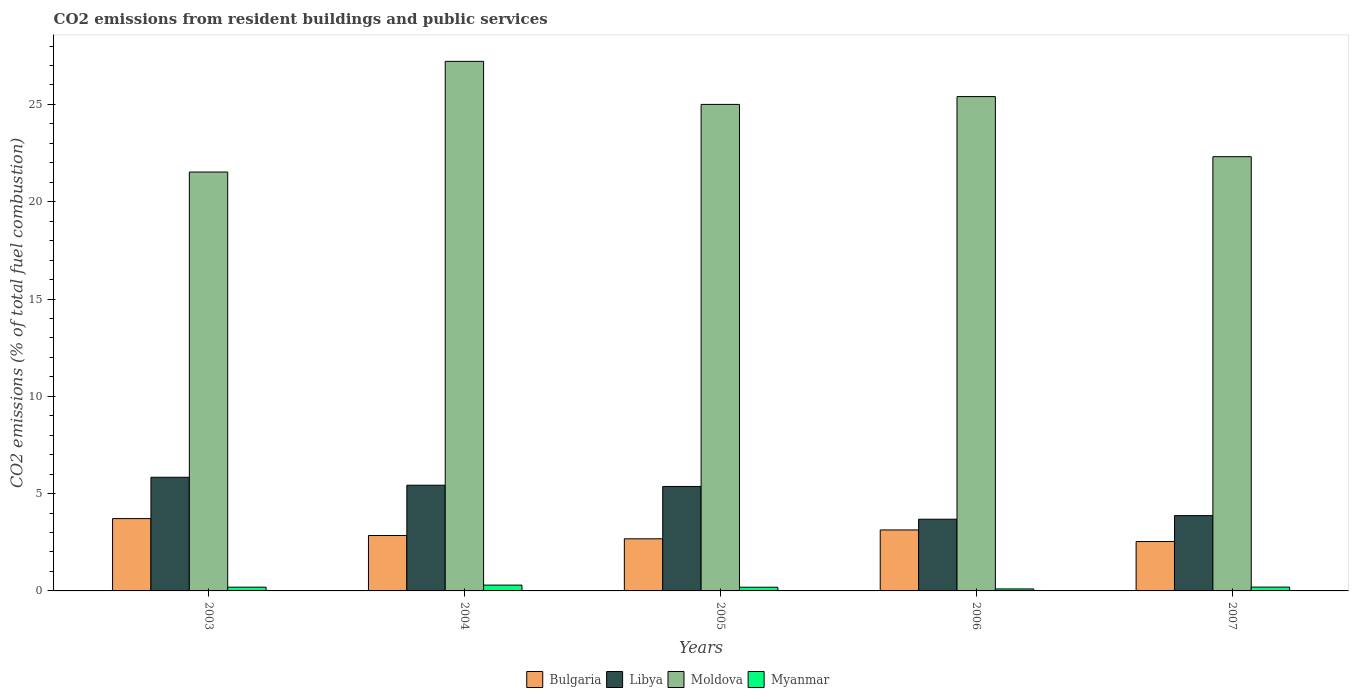How many different coloured bars are there?
Make the answer very short. 4. How many groups of bars are there?
Make the answer very short. 5. Are the number of bars per tick equal to the number of legend labels?
Your answer should be very brief. Yes. How many bars are there on the 2nd tick from the right?
Ensure brevity in your answer.  4. In how many cases, is the number of bars for a given year not equal to the number of legend labels?
Give a very brief answer. 0. What is the total CO2 emitted in Moldova in 2007?
Your response must be concise. 22.31. Across all years, what is the maximum total CO2 emitted in Bulgaria?
Your response must be concise. 3.72. Across all years, what is the minimum total CO2 emitted in Myanmar?
Offer a very short reply. 0.1. In which year was the total CO2 emitted in Myanmar minimum?
Offer a very short reply. 2006. What is the total total CO2 emitted in Moldova in the graph?
Ensure brevity in your answer.  121.45. What is the difference between the total CO2 emitted in Libya in 2005 and that in 2006?
Your answer should be very brief. 1.68. What is the difference between the total CO2 emitted in Myanmar in 2003 and the total CO2 emitted in Moldova in 2004?
Give a very brief answer. -27.02. What is the average total CO2 emitted in Libya per year?
Provide a short and direct response. 4.84. In the year 2006, what is the difference between the total CO2 emitted in Myanmar and total CO2 emitted in Bulgaria?
Your answer should be compact. -3.03. What is the ratio of the total CO2 emitted in Bulgaria in 2005 to that in 2007?
Keep it short and to the point. 1.06. Is the total CO2 emitted in Myanmar in 2003 less than that in 2005?
Offer a terse response. No. Is the difference between the total CO2 emitted in Myanmar in 2005 and 2007 greater than the difference between the total CO2 emitted in Bulgaria in 2005 and 2007?
Give a very brief answer. No. What is the difference between the highest and the second highest total CO2 emitted in Myanmar?
Your response must be concise. 0.1. What is the difference between the highest and the lowest total CO2 emitted in Moldova?
Provide a short and direct response. 5.69. Is the sum of the total CO2 emitted in Myanmar in 2003 and 2007 greater than the maximum total CO2 emitted in Libya across all years?
Offer a very short reply. No. Is it the case that in every year, the sum of the total CO2 emitted in Moldova and total CO2 emitted in Libya is greater than the sum of total CO2 emitted in Bulgaria and total CO2 emitted in Myanmar?
Your response must be concise. Yes. What does the 4th bar from the left in 2003 represents?
Make the answer very short. Myanmar. What does the 2nd bar from the right in 2006 represents?
Provide a succinct answer. Moldova. Is it the case that in every year, the sum of the total CO2 emitted in Moldova and total CO2 emitted in Myanmar is greater than the total CO2 emitted in Libya?
Offer a very short reply. Yes. How many bars are there?
Your answer should be compact. 20. Are all the bars in the graph horizontal?
Ensure brevity in your answer.  No. How many years are there in the graph?
Offer a terse response. 5. What is the difference between two consecutive major ticks on the Y-axis?
Offer a terse response. 5. Does the graph contain grids?
Offer a terse response. No. Where does the legend appear in the graph?
Provide a short and direct response. Bottom center. How are the legend labels stacked?
Your answer should be compact. Horizontal. What is the title of the graph?
Your answer should be very brief. CO2 emissions from resident buildings and public services. Does "Mauritius" appear as one of the legend labels in the graph?
Provide a succinct answer. No. What is the label or title of the Y-axis?
Your response must be concise. CO2 emissions (% of total fuel combustion). What is the CO2 emissions (% of total fuel combustion) in Bulgaria in 2003?
Make the answer very short. 3.72. What is the CO2 emissions (% of total fuel combustion) in Libya in 2003?
Keep it short and to the point. 5.84. What is the CO2 emissions (% of total fuel combustion) in Moldova in 2003?
Your response must be concise. 21.52. What is the CO2 emissions (% of total fuel combustion) of Myanmar in 2003?
Make the answer very short. 0.19. What is the CO2 emissions (% of total fuel combustion) in Bulgaria in 2004?
Ensure brevity in your answer.  2.85. What is the CO2 emissions (% of total fuel combustion) of Libya in 2004?
Make the answer very short. 5.43. What is the CO2 emissions (% of total fuel combustion) in Moldova in 2004?
Give a very brief answer. 27.21. What is the CO2 emissions (% of total fuel combustion) of Myanmar in 2004?
Offer a terse response. 0.3. What is the CO2 emissions (% of total fuel combustion) in Bulgaria in 2005?
Your answer should be very brief. 2.68. What is the CO2 emissions (% of total fuel combustion) of Libya in 2005?
Provide a succinct answer. 5.37. What is the CO2 emissions (% of total fuel combustion) of Moldova in 2005?
Offer a very short reply. 25. What is the CO2 emissions (% of total fuel combustion) of Myanmar in 2005?
Ensure brevity in your answer.  0.19. What is the CO2 emissions (% of total fuel combustion) of Bulgaria in 2006?
Your response must be concise. 3.13. What is the CO2 emissions (% of total fuel combustion) of Libya in 2006?
Your answer should be compact. 3.68. What is the CO2 emissions (% of total fuel combustion) of Moldova in 2006?
Make the answer very short. 25.4. What is the CO2 emissions (% of total fuel combustion) in Myanmar in 2006?
Your response must be concise. 0.1. What is the CO2 emissions (% of total fuel combustion) in Bulgaria in 2007?
Make the answer very short. 2.54. What is the CO2 emissions (% of total fuel combustion) in Libya in 2007?
Your response must be concise. 3.87. What is the CO2 emissions (% of total fuel combustion) of Moldova in 2007?
Offer a very short reply. 22.31. What is the CO2 emissions (% of total fuel combustion) of Myanmar in 2007?
Keep it short and to the point. 0.2. Across all years, what is the maximum CO2 emissions (% of total fuel combustion) of Bulgaria?
Offer a terse response. 3.72. Across all years, what is the maximum CO2 emissions (% of total fuel combustion) of Libya?
Your response must be concise. 5.84. Across all years, what is the maximum CO2 emissions (% of total fuel combustion) of Moldova?
Make the answer very short. 27.21. Across all years, what is the maximum CO2 emissions (% of total fuel combustion) of Myanmar?
Offer a very short reply. 0.3. Across all years, what is the minimum CO2 emissions (% of total fuel combustion) of Bulgaria?
Offer a terse response. 2.54. Across all years, what is the minimum CO2 emissions (% of total fuel combustion) in Libya?
Give a very brief answer. 3.68. Across all years, what is the minimum CO2 emissions (% of total fuel combustion) of Moldova?
Give a very brief answer. 21.52. Across all years, what is the minimum CO2 emissions (% of total fuel combustion) in Myanmar?
Give a very brief answer. 0.1. What is the total CO2 emissions (% of total fuel combustion) of Bulgaria in the graph?
Provide a short and direct response. 14.91. What is the total CO2 emissions (% of total fuel combustion) of Libya in the graph?
Ensure brevity in your answer.  24.19. What is the total CO2 emissions (% of total fuel combustion) of Moldova in the graph?
Make the answer very short. 121.45. What is the total CO2 emissions (% of total fuel combustion) of Myanmar in the graph?
Offer a terse response. 0.98. What is the difference between the CO2 emissions (% of total fuel combustion) in Bulgaria in 2003 and that in 2004?
Your answer should be very brief. 0.87. What is the difference between the CO2 emissions (% of total fuel combustion) in Libya in 2003 and that in 2004?
Your answer should be compact. 0.41. What is the difference between the CO2 emissions (% of total fuel combustion) in Moldova in 2003 and that in 2004?
Offer a very short reply. -5.69. What is the difference between the CO2 emissions (% of total fuel combustion) of Myanmar in 2003 and that in 2004?
Keep it short and to the point. -0.11. What is the difference between the CO2 emissions (% of total fuel combustion) of Bulgaria in 2003 and that in 2005?
Offer a very short reply. 1.04. What is the difference between the CO2 emissions (% of total fuel combustion) of Libya in 2003 and that in 2005?
Give a very brief answer. 0.47. What is the difference between the CO2 emissions (% of total fuel combustion) in Moldova in 2003 and that in 2005?
Ensure brevity in your answer.  -3.48. What is the difference between the CO2 emissions (% of total fuel combustion) in Myanmar in 2003 and that in 2005?
Offer a very short reply. 0. What is the difference between the CO2 emissions (% of total fuel combustion) of Bulgaria in 2003 and that in 2006?
Ensure brevity in your answer.  0.58. What is the difference between the CO2 emissions (% of total fuel combustion) in Libya in 2003 and that in 2006?
Offer a terse response. 2.15. What is the difference between the CO2 emissions (% of total fuel combustion) in Moldova in 2003 and that in 2006?
Offer a terse response. -3.88. What is the difference between the CO2 emissions (% of total fuel combustion) of Myanmar in 2003 and that in 2006?
Offer a terse response. 0.09. What is the difference between the CO2 emissions (% of total fuel combustion) in Bulgaria in 2003 and that in 2007?
Make the answer very short. 1.18. What is the difference between the CO2 emissions (% of total fuel combustion) in Libya in 2003 and that in 2007?
Your answer should be compact. 1.97. What is the difference between the CO2 emissions (% of total fuel combustion) of Moldova in 2003 and that in 2007?
Provide a succinct answer. -0.79. What is the difference between the CO2 emissions (% of total fuel combustion) in Myanmar in 2003 and that in 2007?
Ensure brevity in your answer.  -0. What is the difference between the CO2 emissions (% of total fuel combustion) of Bulgaria in 2004 and that in 2005?
Provide a succinct answer. 0.17. What is the difference between the CO2 emissions (% of total fuel combustion) of Libya in 2004 and that in 2005?
Your answer should be very brief. 0.06. What is the difference between the CO2 emissions (% of total fuel combustion) in Moldova in 2004 and that in 2005?
Ensure brevity in your answer.  2.21. What is the difference between the CO2 emissions (% of total fuel combustion) of Myanmar in 2004 and that in 2005?
Offer a very short reply. 0.11. What is the difference between the CO2 emissions (% of total fuel combustion) in Bulgaria in 2004 and that in 2006?
Your answer should be very brief. -0.29. What is the difference between the CO2 emissions (% of total fuel combustion) in Libya in 2004 and that in 2006?
Your answer should be compact. 1.75. What is the difference between the CO2 emissions (% of total fuel combustion) in Moldova in 2004 and that in 2006?
Make the answer very short. 1.81. What is the difference between the CO2 emissions (% of total fuel combustion) of Myanmar in 2004 and that in 2006?
Ensure brevity in your answer.  0.2. What is the difference between the CO2 emissions (% of total fuel combustion) in Bulgaria in 2004 and that in 2007?
Your answer should be very brief. 0.31. What is the difference between the CO2 emissions (% of total fuel combustion) of Libya in 2004 and that in 2007?
Your answer should be very brief. 1.56. What is the difference between the CO2 emissions (% of total fuel combustion) of Moldova in 2004 and that in 2007?
Offer a terse response. 4.9. What is the difference between the CO2 emissions (% of total fuel combustion) of Myanmar in 2004 and that in 2007?
Give a very brief answer. 0.1. What is the difference between the CO2 emissions (% of total fuel combustion) of Bulgaria in 2005 and that in 2006?
Ensure brevity in your answer.  -0.45. What is the difference between the CO2 emissions (% of total fuel combustion) in Libya in 2005 and that in 2006?
Ensure brevity in your answer.  1.68. What is the difference between the CO2 emissions (% of total fuel combustion) of Moldova in 2005 and that in 2006?
Your answer should be compact. -0.4. What is the difference between the CO2 emissions (% of total fuel combustion) of Myanmar in 2005 and that in 2006?
Your response must be concise. 0.09. What is the difference between the CO2 emissions (% of total fuel combustion) of Bulgaria in 2005 and that in 2007?
Offer a very short reply. 0.14. What is the difference between the CO2 emissions (% of total fuel combustion) in Libya in 2005 and that in 2007?
Your answer should be very brief. 1.5. What is the difference between the CO2 emissions (% of total fuel combustion) in Moldova in 2005 and that in 2007?
Make the answer very short. 2.69. What is the difference between the CO2 emissions (% of total fuel combustion) of Myanmar in 2005 and that in 2007?
Give a very brief answer. -0.01. What is the difference between the CO2 emissions (% of total fuel combustion) in Bulgaria in 2006 and that in 2007?
Keep it short and to the point. 0.6. What is the difference between the CO2 emissions (% of total fuel combustion) of Libya in 2006 and that in 2007?
Provide a short and direct response. -0.19. What is the difference between the CO2 emissions (% of total fuel combustion) of Moldova in 2006 and that in 2007?
Provide a succinct answer. 3.09. What is the difference between the CO2 emissions (% of total fuel combustion) of Myanmar in 2006 and that in 2007?
Provide a succinct answer. -0.09. What is the difference between the CO2 emissions (% of total fuel combustion) in Bulgaria in 2003 and the CO2 emissions (% of total fuel combustion) in Libya in 2004?
Provide a succinct answer. -1.72. What is the difference between the CO2 emissions (% of total fuel combustion) of Bulgaria in 2003 and the CO2 emissions (% of total fuel combustion) of Moldova in 2004?
Give a very brief answer. -23.5. What is the difference between the CO2 emissions (% of total fuel combustion) of Bulgaria in 2003 and the CO2 emissions (% of total fuel combustion) of Myanmar in 2004?
Offer a terse response. 3.42. What is the difference between the CO2 emissions (% of total fuel combustion) in Libya in 2003 and the CO2 emissions (% of total fuel combustion) in Moldova in 2004?
Keep it short and to the point. -21.37. What is the difference between the CO2 emissions (% of total fuel combustion) in Libya in 2003 and the CO2 emissions (% of total fuel combustion) in Myanmar in 2004?
Your answer should be very brief. 5.54. What is the difference between the CO2 emissions (% of total fuel combustion) of Moldova in 2003 and the CO2 emissions (% of total fuel combustion) of Myanmar in 2004?
Make the answer very short. 21.23. What is the difference between the CO2 emissions (% of total fuel combustion) of Bulgaria in 2003 and the CO2 emissions (% of total fuel combustion) of Libya in 2005?
Offer a terse response. -1.65. What is the difference between the CO2 emissions (% of total fuel combustion) in Bulgaria in 2003 and the CO2 emissions (% of total fuel combustion) in Moldova in 2005?
Provide a short and direct response. -21.28. What is the difference between the CO2 emissions (% of total fuel combustion) of Bulgaria in 2003 and the CO2 emissions (% of total fuel combustion) of Myanmar in 2005?
Provide a succinct answer. 3.53. What is the difference between the CO2 emissions (% of total fuel combustion) in Libya in 2003 and the CO2 emissions (% of total fuel combustion) in Moldova in 2005?
Keep it short and to the point. -19.16. What is the difference between the CO2 emissions (% of total fuel combustion) of Libya in 2003 and the CO2 emissions (% of total fuel combustion) of Myanmar in 2005?
Keep it short and to the point. 5.65. What is the difference between the CO2 emissions (% of total fuel combustion) of Moldova in 2003 and the CO2 emissions (% of total fuel combustion) of Myanmar in 2005?
Offer a very short reply. 21.34. What is the difference between the CO2 emissions (% of total fuel combustion) of Bulgaria in 2003 and the CO2 emissions (% of total fuel combustion) of Libya in 2006?
Your answer should be very brief. 0.03. What is the difference between the CO2 emissions (% of total fuel combustion) in Bulgaria in 2003 and the CO2 emissions (% of total fuel combustion) in Moldova in 2006?
Offer a very short reply. -21.68. What is the difference between the CO2 emissions (% of total fuel combustion) of Bulgaria in 2003 and the CO2 emissions (% of total fuel combustion) of Myanmar in 2006?
Your response must be concise. 3.61. What is the difference between the CO2 emissions (% of total fuel combustion) of Libya in 2003 and the CO2 emissions (% of total fuel combustion) of Moldova in 2006?
Your answer should be compact. -19.56. What is the difference between the CO2 emissions (% of total fuel combustion) in Libya in 2003 and the CO2 emissions (% of total fuel combustion) in Myanmar in 2006?
Your answer should be very brief. 5.74. What is the difference between the CO2 emissions (% of total fuel combustion) of Moldova in 2003 and the CO2 emissions (% of total fuel combustion) of Myanmar in 2006?
Your response must be concise. 21.42. What is the difference between the CO2 emissions (% of total fuel combustion) in Bulgaria in 2003 and the CO2 emissions (% of total fuel combustion) in Libya in 2007?
Your answer should be compact. -0.15. What is the difference between the CO2 emissions (% of total fuel combustion) of Bulgaria in 2003 and the CO2 emissions (% of total fuel combustion) of Moldova in 2007?
Offer a very short reply. -18.6. What is the difference between the CO2 emissions (% of total fuel combustion) in Bulgaria in 2003 and the CO2 emissions (% of total fuel combustion) in Myanmar in 2007?
Ensure brevity in your answer.  3.52. What is the difference between the CO2 emissions (% of total fuel combustion) of Libya in 2003 and the CO2 emissions (% of total fuel combustion) of Moldova in 2007?
Offer a very short reply. -16.47. What is the difference between the CO2 emissions (% of total fuel combustion) of Libya in 2003 and the CO2 emissions (% of total fuel combustion) of Myanmar in 2007?
Offer a terse response. 5.64. What is the difference between the CO2 emissions (% of total fuel combustion) in Moldova in 2003 and the CO2 emissions (% of total fuel combustion) in Myanmar in 2007?
Provide a short and direct response. 21.33. What is the difference between the CO2 emissions (% of total fuel combustion) of Bulgaria in 2004 and the CO2 emissions (% of total fuel combustion) of Libya in 2005?
Provide a succinct answer. -2.52. What is the difference between the CO2 emissions (% of total fuel combustion) of Bulgaria in 2004 and the CO2 emissions (% of total fuel combustion) of Moldova in 2005?
Keep it short and to the point. -22.15. What is the difference between the CO2 emissions (% of total fuel combustion) of Bulgaria in 2004 and the CO2 emissions (% of total fuel combustion) of Myanmar in 2005?
Keep it short and to the point. 2.66. What is the difference between the CO2 emissions (% of total fuel combustion) in Libya in 2004 and the CO2 emissions (% of total fuel combustion) in Moldova in 2005?
Provide a succinct answer. -19.57. What is the difference between the CO2 emissions (% of total fuel combustion) in Libya in 2004 and the CO2 emissions (% of total fuel combustion) in Myanmar in 2005?
Your answer should be very brief. 5.24. What is the difference between the CO2 emissions (% of total fuel combustion) in Moldova in 2004 and the CO2 emissions (% of total fuel combustion) in Myanmar in 2005?
Your answer should be very brief. 27.02. What is the difference between the CO2 emissions (% of total fuel combustion) of Bulgaria in 2004 and the CO2 emissions (% of total fuel combustion) of Libya in 2006?
Make the answer very short. -0.84. What is the difference between the CO2 emissions (% of total fuel combustion) in Bulgaria in 2004 and the CO2 emissions (% of total fuel combustion) in Moldova in 2006?
Offer a very short reply. -22.55. What is the difference between the CO2 emissions (% of total fuel combustion) of Bulgaria in 2004 and the CO2 emissions (% of total fuel combustion) of Myanmar in 2006?
Give a very brief answer. 2.74. What is the difference between the CO2 emissions (% of total fuel combustion) of Libya in 2004 and the CO2 emissions (% of total fuel combustion) of Moldova in 2006?
Make the answer very short. -19.97. What is the difference between the CO2 emissions (% of total fuel combustion) of Libya in 2004 and the CO2 emissions (% of total fuel combustion) of Myanmar in 2006?
Provide a short and direct response. 5.33. What is the difference between the CO2 emissions (% of total fuel combustion) of Moldova in 2004 and the CO2 emissions (% of total fuel combustion) of Myanmar in 2006?
Ensure brevity in your answer.  27.11. What is the difference between the CO2 emissions (% of total fuel combustion) of Bulgaria in 2004 and the CO2 emissions (% of total fuel combustion) of Libya in 2007?
Give a very brief answer. -1.02. What is the difference between the CO2 emissions (% of total fuel combustion) in Bulgaria in 2004 and the CO2 emissions (% of total fuel combustion) in Moldova in 2007?
Offer a terse response. -19.47. What is the difference between the CO2 emissions (% of total fuel combustion) in Bulgaria in 2004 and the CO2 emissions (% of total fuel combustion) in Myanmar in 2007?
Your response must be concise. 2.65. What is the difference between the CO2 emissions (% of total fuel combustion) in Libya in 2004 and the CO2 emissions (% of total fuel combustion) in Moldova in 2007?
Provide a succinct answer. -16.88. What is the difference between the CO2 emissions (% of total fuel combustion) of Libya in 2004 and the CO2 emissions (% of total fuel combustion) of Myanmar in 2007?
Ensure brevity in your answer.  5.24. What is the difference between the CO2 emissions (% of total fuel combustion) of Moldova in 2004 and the CO2 emissions (% of total fuel combustion) of Myanmar in 2007?
Keep it short and to the point. 27.02. What is the difference between the CO2 emissions (% of total fuel combustion) of Bulgaria in 2005 and the CO2 emissions (% of total fuel combustion) of Libya in 2006?
Offer a very short reply. -1.01. What is the difference between the CO2 emissions (% of total fuel combustion) of Bulgaria in 2005 and the CO2 emissions (% of total fuel combustion) of Moldova in 2006?
Your answer should be very brief. -22.72. What is the difference between the CO2 emissions (% of total fuel combustion) of Bulgaria in 2005 and the CO2 emissions (% of total fuel combustion) of Myanmar in 2006?
Keep it short and to the point. 2.58. What is the difference between the CO2 emissions (% of total fuel combustion) in Libya in 2005 and the CO2 emissions (% of total fuel combustion) in Moldova in 2006?
Make the answer very short. -20.03. What is the difference between the CO2 emissions (% of total fuel combustion) of Libya in 2005 and the CO2 emissions (% of total fuel combustion) of Myanmar in 2006?
Keep it short and to the point. 5.27. What is the difference between the CO2 emissions (% of total fuel combustion) in Moldova in 2005 and the CO2 emissions (% of total fuel combustion) in Myanmar in 2006?
Provide a short and direct response. 24.9. What is the difference between the CO2 emissions (% of total fuel combustion) in Bulgaria in 2005 and the CO2 emissions (% of total fuel combustion) in Libya in 2007?
Offer a terse response. -1.19. What is the difference between the CO2 emissions (% of total fuel combustion) of Bulgaria in 2005 and the CO2 emissions (% of total fuel combustion) of Moldova in 2007?
Keep it short and to the point. -19.63. What is the difference between the CO2 emissions (% of total fuel combustion) in Bulgaria in 2005 and the CO2 emissions (% of total fuel combustion) in Myanmar in 2007?
Your answer should be compact. 2.48. What is the difference between the CO2 emissions (% of total fuel combustion) of Libya in 2005 and the CO2 emissions (% of total fuel combustion) of Moldova in 2007?
Your response must be concise. -16.95. What is the difference between the CO2 emissions (% of total fuel combustion) in Libya in 2005 and the CO2 emissions (% of total fuel combustion) in Myanmar in 2007?
Offer a very short reply. 5.17. What is the difference between the CO2 emissions (% of total fuel combustion) of Moldova in 2005 and the CO2 emissions (% of total fuel combustion) of Myanmar in 2007?
Your response must be concise. 24.8. What is the difference between the CO2 emissions (% of total fuel combustion) of Bulgaria in 2006 and the CO2 emissions (% of total fuel combustion) of Libya in 2007?
Provide a succinct answer. -0.74. What is the difference between the CO2 emissions (% of total fuel combustion) of Bulgaria in 2006 and the CO2 emissions (% of total fuel combustion) of Moldova in 2007?
Give a very brief answer. -19.18. What is the difference between the CO2 emissions (% of total fuel combustion) in Bulgaria in 2006 and the CO2 emissions (% of total fuel combustion) in Myanmar in 2007?
Make the answer very short. 2.94. What is the difference between the CO2 emissions (% of total fuel combustion) of Libya in 2006 and the CO2 emissions (% of total fuel combustion) of Moldova in 2007?
Make the answer very short. -18.63. What is the difference between the CO2 emissions (% of total fuel combustion) in Libya in 2006 and the CO2 emissions (% of total fuel combustion) in Myanmar in 2007?
Provide a short and direct response. 3.49. What is the difference between the CO2 emissions (% of total fuel combustion) in Moldova in 2006 and the CO2 emissions (% of total fuel combustion) in Myanmar in 2007?
Your answer should be very brief. 25.2. What is the average CO2 emissions (% of total fuel combustion) of Bulgaria per year?
Your response must be concise. 2.98. What is the average CO2 emissions (% of total fuel combustion) in Libya per year?
Your response must be concise. 4.84. What is the average CO2 emissions (% of total fuel combustion) of Moldova per year?
Your answer should be compact. 24.29. What is the average CO2 emissions (% of total fuel combustion) in Myanmar per year?
Make the answer very short. 0.2. In the year 2003, what is the difference between the CO2 emissions (% of total fuel combustion) in Bulgaria and CO2 emissions (% of total fuel combustion) in Libya?
Make the answer very short. -2.12. In the year 2003, what is the difference between the CO2 emissions (% of total fuel combustion) of Bulgaria and CO2 emissions (% of total fuel combustion) of Moldova?
Offer a terse response. -17.81. In the year 2003, what is the difference between the CO2 emissions (% of total fuel combustion) in Bulgaria and CO2 emissions (% of total fuel combustion) in Myanmar?
Give a very brief answer. 3.52. In the year 2003, what is the difference between the CO2 emissions (% of total fuel combustion) of Libya and CO2 emissions (% of total fuel combustion) of Moldova?
Make the answer very short. -15.68. In the year 2003, what is the difference between the CO2 emissions (% of total fuel combustion) of Libya and CO2 emissions (% of total fuel combustion) of Myanmar?
Your answer should be compact. 5.65. In the year 2003, what is the difference between the CO2 emissions (% of total fuel combustion) of Moldova and CO2 emissions (% of total fuel combustion) of Myanmar?
Provide a short and direct response. 21.33. In the year 2004, what is the difference between the CO2 emissions (% of total fuel combustion) in Bulgaria and CO2 emissions (% of total fuel combustion) in Libya?
Provide a succinct answer. -2.59. In the year 2004, what is the difference between the CO2 emissions (% of total fuel combustion) in Bulgaria and CO2 emissions (% of total fuel combustion) in Moldova?
Your response must be concise. -24.37. In the year 2004, what is the difference between the CO2 emissions (% of total fuel combustion) in Bulgaria and CO2 emissions (% of total fuel combustion) in Myanmar?
Ensure brevity in your answer.  2.55. In the year 2004, what is the difference between the CO2 emissions (% of total fuel combustion) in Libya and CO2 emissions (% of total fuel combustion) in Moldova?
Provide a succinct answer. -21.78. In the year 2004, what is the difference between the CO2 emissions (% of total fuel combustion) in Libya and CO2 emissions (% of total fuel combustion) in Myanmar?
Offer a very short reply. 5.13. In the year 2004, what is the difference between the CO2 emissions (% of total fuel combustion) of Moldova and CO2 emissions (% of total fuel combustion) of Myanmar?
Make the answer very short. 26.91. In the year 2005, what is the difference between the CO2 emissions (% of total fuel combustion) in Bulgaria and CO2 emissions (% of total fuel combustion) in Libya?
Provide a short and direct response. -2.69. In the year 2005, what is the difference between the CO2 emissions (% of total fuel combustion) in Bulgaria and CO2 emissions (% of total fuel combustion) in Moldova?
Offer a terse response. -22.32. In the year 2005, what is the difference between the CO2 emissions (% of total fuel combustion) in Bulgaria and CO2 emissions (% of total fuel combustion) in Myanmar?
Make the answer very short. 2.49. In the year 2005, what is the difference between the CO2 emissions (% of total fuel combustion) of Libya and CO2 emissions (% of total fuel combustion) of Moldova?
Your response must be concise. -19.63. In the year 2005, what is the difference between the CO2 emissions (% of total fuel combustion) of Libya and CO2 emissions (% of total fuel combustion) of Myanmar?
Your response must be concise. 5.18. In the year 2005, what is the difference between the CO2 emissions (% of total fuel combustion) of Moldova and CO2 emissions (% of total fuel combustion) of Myanmar?
Give a very brief answer. 24.81. In the year 2006, what is the difference between the CO2 emissions (% of total fuel combustion) in Bulgaria and CO2 emissions (% of total fuel combustion) in Libya?
Give a very brief answer. -0.55. In the year 2006, what is the difference between the CO2 emissions (% of total fuel combustion) of Bulgaria and CO2 emissions (% of total fuel combustion) of Moldova?
Provide a short and direct response. -22.27. In the year 2006, what is the difference between the CO2 emissions (% of total fuel combustion) of Bulgaria and CO2 emissions (% of total fuel combustion) of Myanmar?
Your answer should be compact. 3.03. In the year 2006, what is the difference between the CO2 emissions (% of total fuel combustion) in Libya and CO2 emissions (% of total fuel combustion) in Moldova?
Offer a terse response. -21.72. In the year 2006, what is the difference between the CO2 emissions (% of total fuel combustion) of Libya and CO2 emissions (% of total fuel combustion) of Myanmar?
Keep it short and to the point. 3.58. In the year 2006, what is the difference between the CO2 emissions (% of total fuel combustion) in Moldova and CO2 emissions (% of total fuel combustion) in Myanmar?
Your response must be concise. 25.3. In the year 2007, what is the difference between the CO2 emissions (% of total fuel combustion) of Bulgaria and CO2 emissions (% of total fuel combustion) of Libya?
Make the answer very short. -1.33. In the year 2007, what is the difference between the CO2 emissions (% of total fuel combustion) in Bulgaria and CO2 emissions (% of total fuel combustion) in Moldova?
Make the answer very short. -19.78. In the year 2007, what is the difference between the CO2 emissions (% of total fuel combustion) in Bulgaria and CO2 emissions (% of total fuel combustion) in Myanmar?
Provide a short and direct response. 2.34. In the year 2007, what is the difference between the CO2 emissions (% of total fuel combustion) in Libya and CO2 emissions (% of total fuel combustion) in Moldova?
Offer a very short reply. -18.44. In the year 2007, what is the difference between the CO2 emissions (% of total fuel combustion) of Libya and CO2 emissions (% of total fuel combustion) of Myanmar?
Your answer should be compact. 3.67. In the year 2007, what is the difference between the CO2 emissions (% of total fuel combustion) of Moldova and CO2 emissions (% of total fuel combustion) of Myanmar?
Provide a succinct answer. 22.12. What is the ratio of the CO2 emissions (% of total fuel combustion) in Bulgaria in 2003 to that in 2004?
Your answer should be very brief. 1.31. What is the ratio of the CO2 emissions (% of total fuel combustion) in Libya in 2003 to that in 2004?
Your response must be concise. 1.07. What is the ratio of the CO2 emissions (% of total fuel combustion) of Moldova in 2003 to that in 2004?
Offer a very short reply. 0.79. What is the ratio of the CO2 emissions (% of total fuel combustion) in Myanmar in 2003 to that in 2004?
Provide a short and direct response. 0.65. What is the ratio of the CO2 emissions (% of total fuel combustion) of Bulgaria in 2003 to that in 2005?
Your answer should be compact. 1.39. What is the ratio of the CO2 emissions (% of total fuel combustion) in Libya in 2003 to that in 2005?
Offer a terse response. 1.09. What is the ratio of the CO2 emissions (% of total fuel combustion) of Moldova in 2003 to that in 2005?
Ensure brevity in your answer.  0.86. What is the ratio of the CO2 emissions (% of total fuel combustion) of Myanmar in 2003 to that in 2005?
Your response must be concise. 1.02. What is the ratio of the CO2 emissions (% of total fuel combustion) in Bulgaria in 2003 to that in 2006?
Provide a short and direct response. 1.19. What is the ratio of the CO2 emissions (% of total fuel combustion) of Libya in 2003 to that in 2006?
Your answer should be very brief. 1.58. What is the ratio of the CO2 emissions (% of total fuel combustion) in Moldova in 2003 to that in 2006?
Provide a short and direct response. 0.85. What is the ratio of the CO2 emissions (% of total fuel combustion) of Myanmar in 2003 to that in 2006?
Ensure brevity in your answer.  1.89. What is the ratio of the CO2 emissions (% of total fuel combustion) of Bulgaria in 2003 to that in 2007?
Make the answer very short. 1.46. What is the ratio of the CO2 emissions (% of total fuel combustion) of Libya in 2003 to that in 2007?
Ensure brevity in your answer.  1.51. What is the ratio of the CO2 emissions (% of total fuel combustion) in Moldova in 2003 to that in 2007?
Your answer should be very brief. 0.96. What is the ratio of the CO2 emissions (% of total fuel combustion) of Myanmar in 2003 to that in 2007?
Your response must be concise. 0.98. What is the ratio of the CO2 emissions (% of total fuel combustion) in Bulgaria in 2004 to that in 2005?
Ensure brevity in your answer.  1.06. What is the ratio of the CO2 emissions (% of total fuel combustion) of Libya in 2004 to that in 2005?
Keep it short and to the point. 1.01. What is the ratio of the CO2 emissions (% of total fuel combustion) of Moldova in 2004 to that in 2005?
Offer a terse response. 1.09. What is the ratio of the CO2 emissions (% of total fuel combustion) in Myanmar in 2004 to that in 2005?
Give a very brief answer. 1.58. What is the ratio of the CO2 emissions (% of total fuel combustion) of Bulgaria in 2004 to that in 2006?
Give a very brief answer. 0.91. What is the ratio of the CO2 emissions (% of total fuel combustion) in Libya in 2004 to that in 2006?
Provide a succinct answer. 1.47. What is the ratio of the CO2 emissions (% of total fuel combustion) in Moldova in 2004 to that in 2006?
Provide a short and direct response. 1.07. What is the ratio of the CO2 emissions (% of total fuel combustion) of Myanmar in 2004 to that in 2006?
Your answer should be very brief. 2.93. What is the ratio of the CO2 emissions (% of total fuel combustion) of Bulgaria in 2004 to that in 2007?
Your answer should be very brief. 1.12. What is the ratio of the CO2 emissions (% of total fuel combustion) of Libya in 2004 to that in 2007?
Ensure brevity in your answer.  1.4. What is the ratio of the CO2 emissions (% of total fuel combustion) in Moldova in 2004 to that in 2007?
Offer a very short reply. 1.22. What is the ratio of the CO2 emissions (% of total fuel combustion) of Myanmar in 2004 to that in 2007?
Make the answer very short. 1.53. What is the ratio of the CO2 emissions (% of total fuel combustion) of Bulgaria in 2005 to that in 2006?
Provide a short and direct response. 0.85. What is the ratio of the CO2 emissions (% of total fuel combustion) of Libya in 2005 to that in 2006?
Your answer should be compact. 1.46. What is the ratio of the CO2 emissions (% of total fuel combustion) of Moldova in 2005 to that in 2006?
Your response must be concise. 0.98. What is the ratio of the CO2 emissions (% of total fuel combustion) of Myanmar in 2005 to that in 2006?
Offer a very short reply. 1.85. What is the ratio of the CO2 emissions (% of total fuel combustion) of Bulgaria in 2005 to that in 2007?
Offer a terse response. 1.06. What is the ratio of the CO2 emissions (% of total fuel combustion) of Libya in 2005 to that in 2007?
Your response must be concise. 1.39. What is the ratio of the CO2 emissions (% of total fuel combustion) in Moldova in 2005 to that in 2007?
Provide a succinct answer. 1.12. What is the ratio of the CO2 emissions (% of total fuel combustion) of Myanmar in 2005 to that in 2007?
Your response must be concise. 0.96. What is the ratio of the CO2 emissions (% of total fuel combustion) of Bulgaria in 2006 to that in 2007?
Your answer should be very brief. 1.23. What is the ratio of the CO2 emissions (% of total fuel combustion) of Libya in 2006 to that in 2007?
Offer a very short reply. 0.95. What is the ratio of the CO2 emissions (% of total fuel combustion) in Moldova in 2006 to that in 2007?
Give a very brief answer. 1.14. What is the ratio of the CO2 emissions (% of total fuel combustion) of Myanmar in 2006 to that in 2007?
Keep it short and to the point. 0.52. What is the difference between the highest and the second highest CO2 emissions (% of total fuel combustion) in Bulgaria?
Provide a succinct answer. 0.58. What is the difference between the highest and the second highest CO2 emissions (% of total fuel combustion) of Libya?
Make the answer very short. 0.41. What is the difference between the highest and the second highest CO2 emissions (% of total fuel combustion) in Moldova?
Offer a very short reply. 1.81. What is the difference between the highest and the second highest CO2 emissions (% of total fuel combustion) in Myanmar?
Provide a short and direct response. 0.1. What is the difference between the highest and the lowest CO2 emissions (% of total fuel combustion) of Bulgaria?
Your answer should be compact. 1.18. What is the difference between the highest and the lowest CO2 emissions (% of total fuel combustion) in Libya?
Give a very brief answer. 2.15. What is the difference between the highest and the lowest CO2 emissions (% of total fuel combustion) of Moldova?
Your answer should be very brief. 5.69. What is the difference between the highest and the lowest CO2 emissions (% of total fuel combustion) in Myanmar?
Provide a succinct answer. 0.2. 